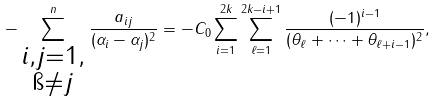<formula> <loc_0><loc_0><loc_500><loc_500>- \sum _ { \substack { i , j = 1 , \\ \i \not = j } } ^ { n } \frac { a _ { i j } } { ( \alpha _ { i } - \alpha _ { j } ) ^ { 2 } } = - C _ { 0 } \sum _ { i = 1 } ^ { 2 k } \sum _ { \ell = 1 } ^ { 2 k - i + 1 } \frac { ( - 1 ) ^ { i - 1 } } { ( \theta _ { \ell } + \cdots + \theta _ { \ell + i - 1 } ) ^ { 2 } } ,</formula> 